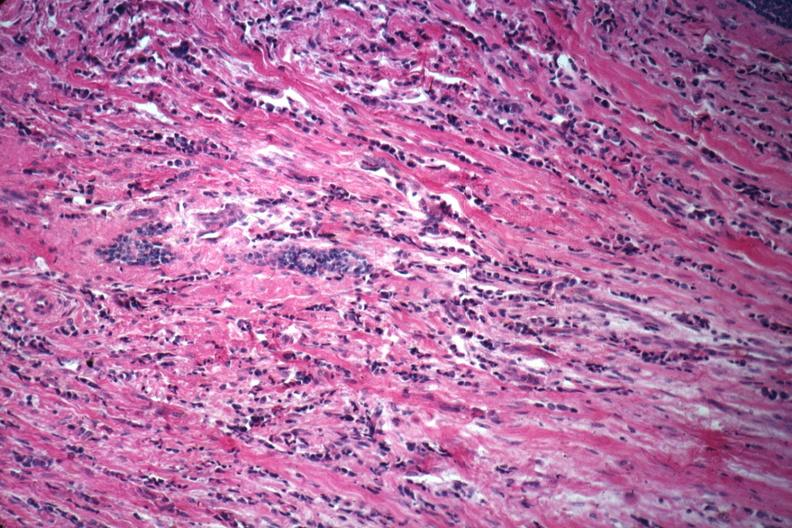how is good example of poorly differentiated infiltrating carcinoma?
Answer the question using a single word or phrase. Ductal 